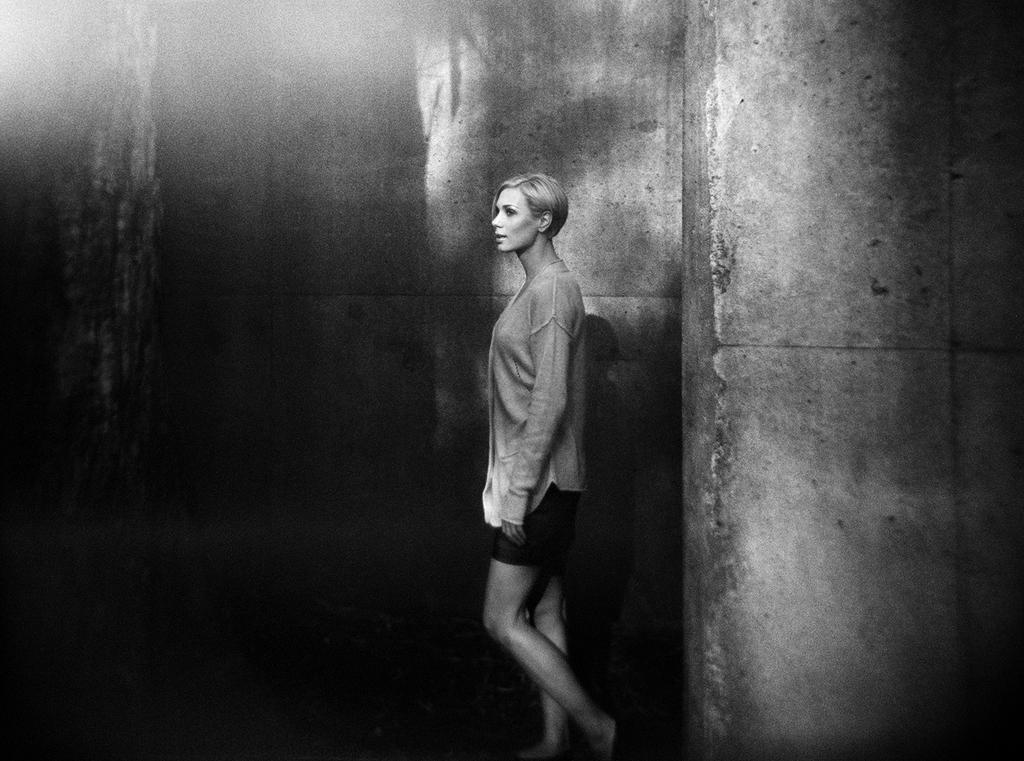What is the color scheme of the image? The image is black and white. What can be seen in the center of the image? There is a person standing in the center of the image. What is visible in the background of the image? There is a wall in the background of the image. What type of action is the slave performing in the image? There is no slave present in the image, and therefore no action can be attributed to a slave. 